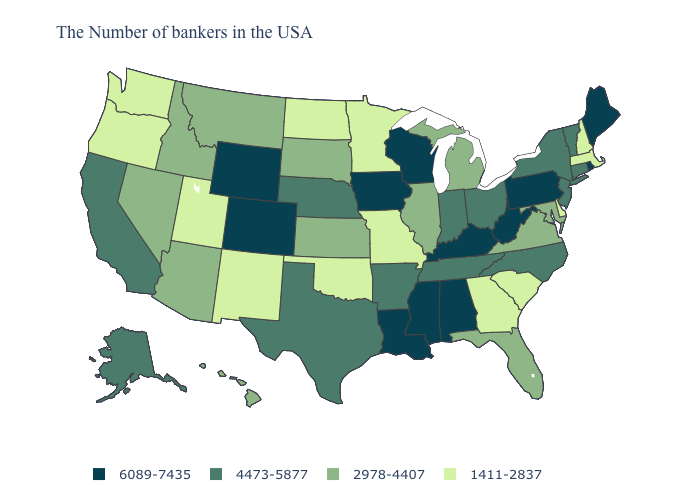Name the states that have a value in the range 4473-5877?
Give a very brief answer. Vermont, Connecticut, New York, New Jersey, North Carolina, Ohio, Indiana, Tennessee, Arkansas, Nebraska, Texas, California, Alaska. Among the states that border Florida , which have the highest value?
Write a very short answer. Alabama. Does the map have missing data?
Be succinct. No. Name the states that have a value in the range 1411-2837?
Give a very brief answer. Massachusetts, New Hampshire, Delaware, South Carolina, Georgia, Missouri, Minnesota, Oklahoma, North Dakota, New Mexico, Utah, Washington, Oregon. Among the states that border Louisiana , which have the lowest value?
Answer briefly. Arkansas, Texas. Does the first symbol in the legend represent the smallest category?
Keep it brief. No. Does the map have missing data?
Short answer required. No. What is the value of Arizona?
Be succinct. 2978-4407. What is the value of Minnesota?
Short answer required. 1411-2837. What is the value of Arkansas?
Give a very brief answer. 4473-5877. Name the states that have a value in the range 2978-4407?
Give a very brief answer. Maryland, Virginia, Florida, Michigan, Illinois, Kansas, South Dakota, Montana, Arizona, Idaho, Nevada, Hawaii. What is the value of New York?
Be succinct. 4473-5877. What is the value of South Dakota?
Concise answer only. 2978-4407. Does the first symbol in the legend represent the smallest category?
Write a very short answer. No. Name the states that have a value in the range 4473-5877?
Answer briefly. Vermont, Connecticut, New York, New Jersey, North Carolina, Ohio, Indiana, Tennessee, Arkansas, Nebraska, Texas, California, Alaska. 